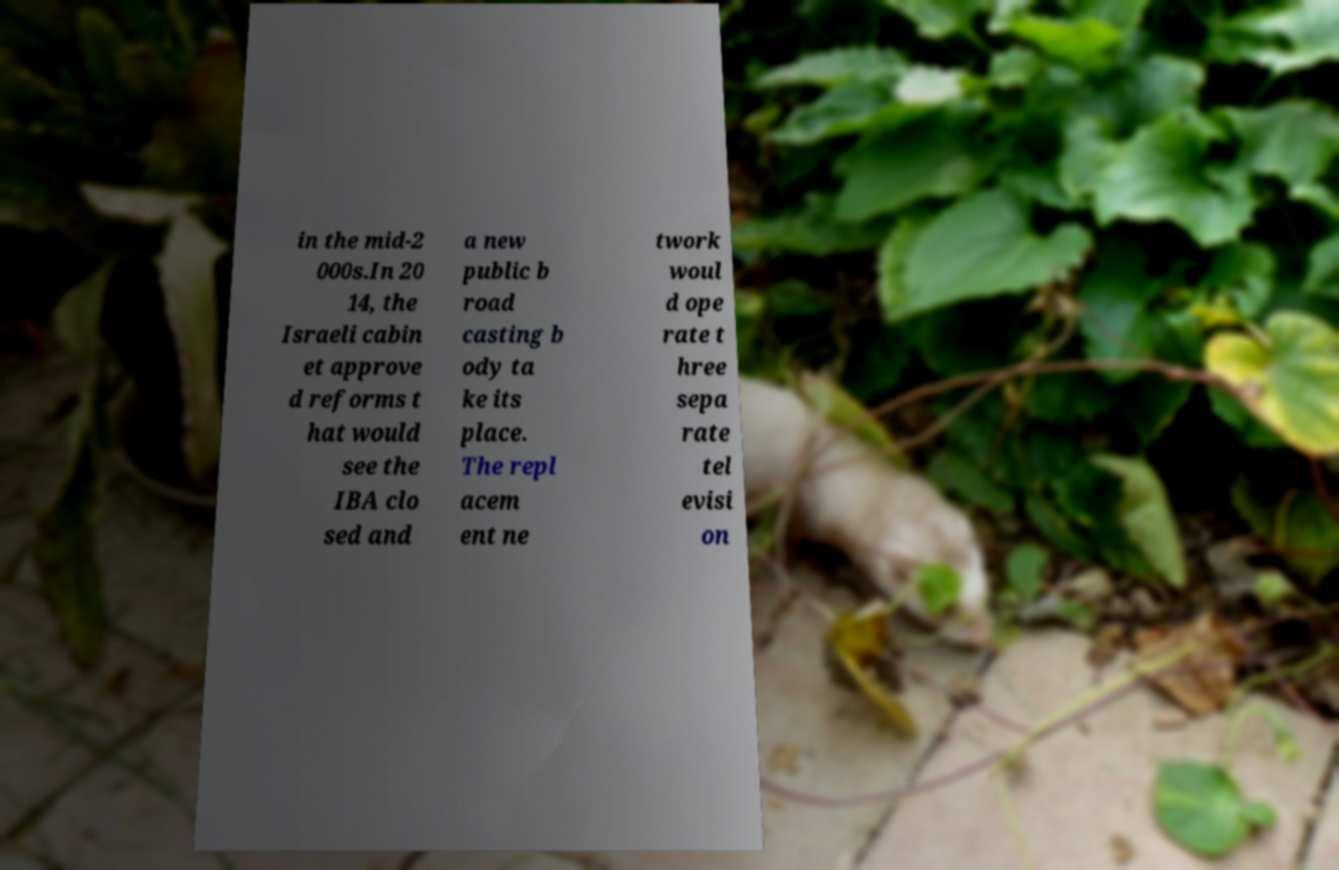Please read and relay the text visible in this image. What does it say? in the mid-2 000s.In 20 14, the Israeli cabin et approve d reforms t hat would see the IBA clo sed and a new public b road casting b ody ta ke its place. The repl acem ent ne twork woul d ope rate t hree sepa rate tel evisi on 